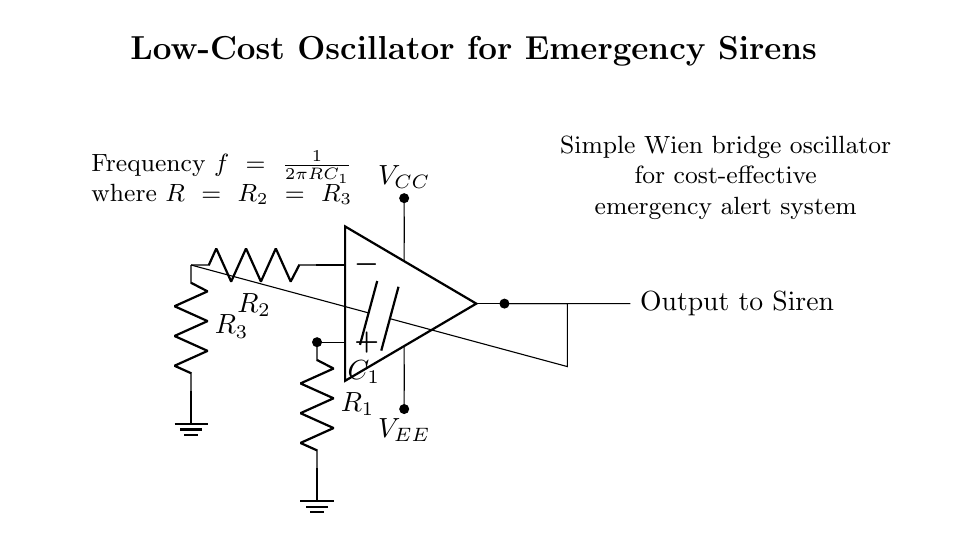What type of oscillator is shown in this circuit? The circuit uses a Wien bridge oscillator configuration, which is evident from the arrangement of the op-amp and the resistors with feedback, common in setting oscillation conditions.
Answer: Wien bridge What is the role of capacitor C1 in this circuit? Capacitor C1 is crucial for determining the frequency of oscillation. It works with the resistors to create a phase shift necessary for oscillation in the Wien bridge configuration.
Answer: Frequency determination What does R1 connect to in the circuit? Resistor R1 connects to the positive terminal of the operational amplifier, which is essential for proper feedback and stabilization of the oscillator.
Answer: Positive terminal What is the expected output of this oscillator? The output is directed towards an emergency siren, serving as the audio signal for alerts within the community system.
Answer: Output to siren How does the frequency relate to the resistors and capacitor? The frequency is calculated using the formula given in the circuit: frequency is inversely proportional to the product of the resistance (R) and the capacitance (C1), where R refers to the equal resistances in the circuit.
Answer: Inverse relationship 